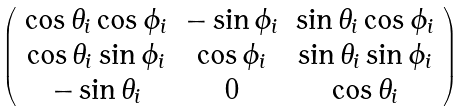<formula> <loc_0><loc_0><loc_500><loc_500>\left ( \begin{array} { c c c } \cos \theta _ { i } \cos \phi _ { i } & - \sin \phi _ { i } & \sin \theta _ { i } \cos \phi _ { i } \\ \cos \theta _ { i } \sin \phi _ { i } & \cos \phi _ { i } & \sin \theta _ { i } \sin \phi _ { i } \\ - \sin \theta _ { i } & 0 & \cos \theta _ { i } \\ \end{array} \right )</formula> 